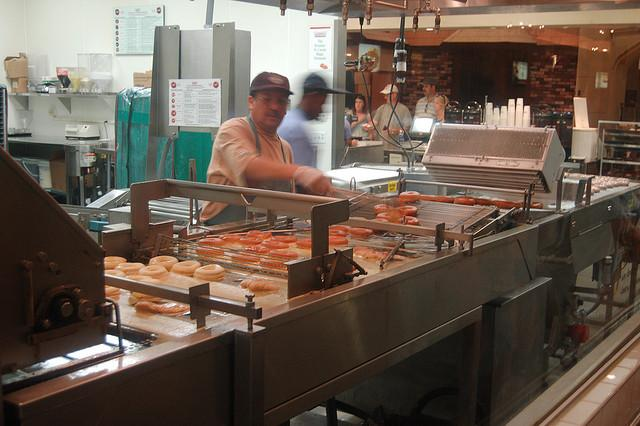What are the people in the background doing? ordering 